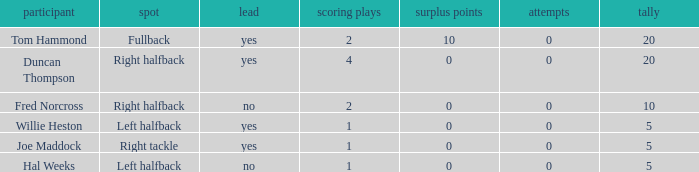How many field goals did duncan thompson have? 0.0. 